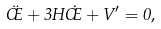<formula> <loc_0><loc_0><loc_500><loc_500>\ddot { \phi } + 3 H \dot { \phi } + V ^ { \prime } = 0 ,</formula> 